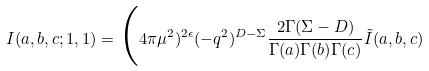Convert formula to latex. <formula><loc_0><loc_0><loc_500><loc_500>I ( a , b , c ; 1 , 1 ) = \Big ( 4 \pi \mu ^ { 2 } ) ^ { 2 \epsilon } ( - q ^ { 2 } ) ^ { D - \Sigma } \frac { 2 \Gamma ( \Sigma - D ) } { \Gamma ( a ) \Gamma ( b ) \Gamma ( c ) } \tilde { I } ( a , b , c )</formula> 